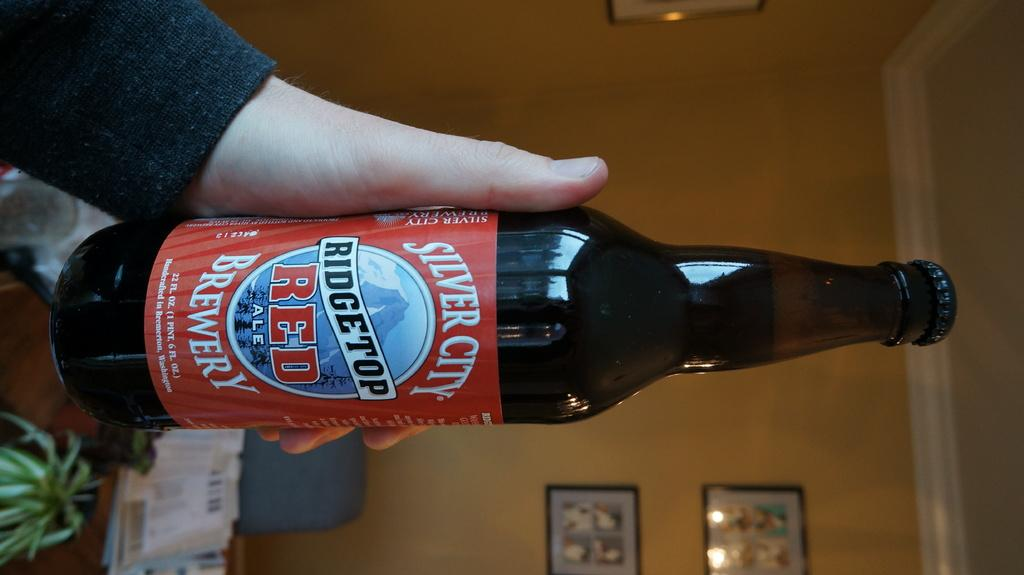<image>
Summarize the visual content of the image. The Silver City Brewery made this bottle of Red ale. 